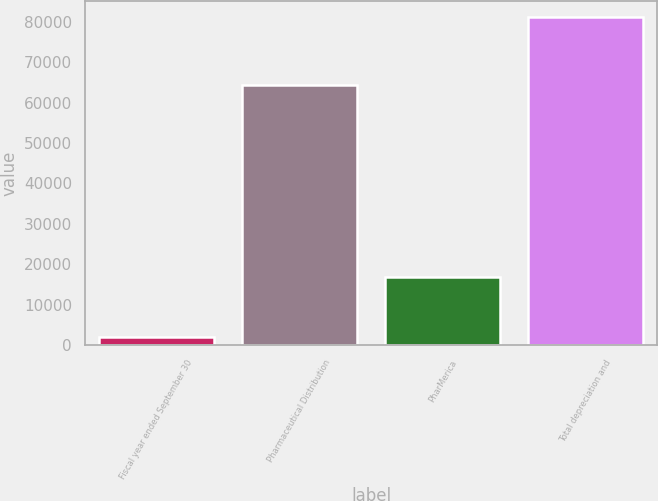<chart> <loc_0><loc_0><loc_500><loc_500><bar_chart><fcel>Fiscal year ended September 30<fcel>Pharmaceutical Distribution<fcel>PharMerica<fcel>Total depreciation and<nl><fcel>2005<fcel>64404<fcel>16795<fcel>81199<nl></chart> 